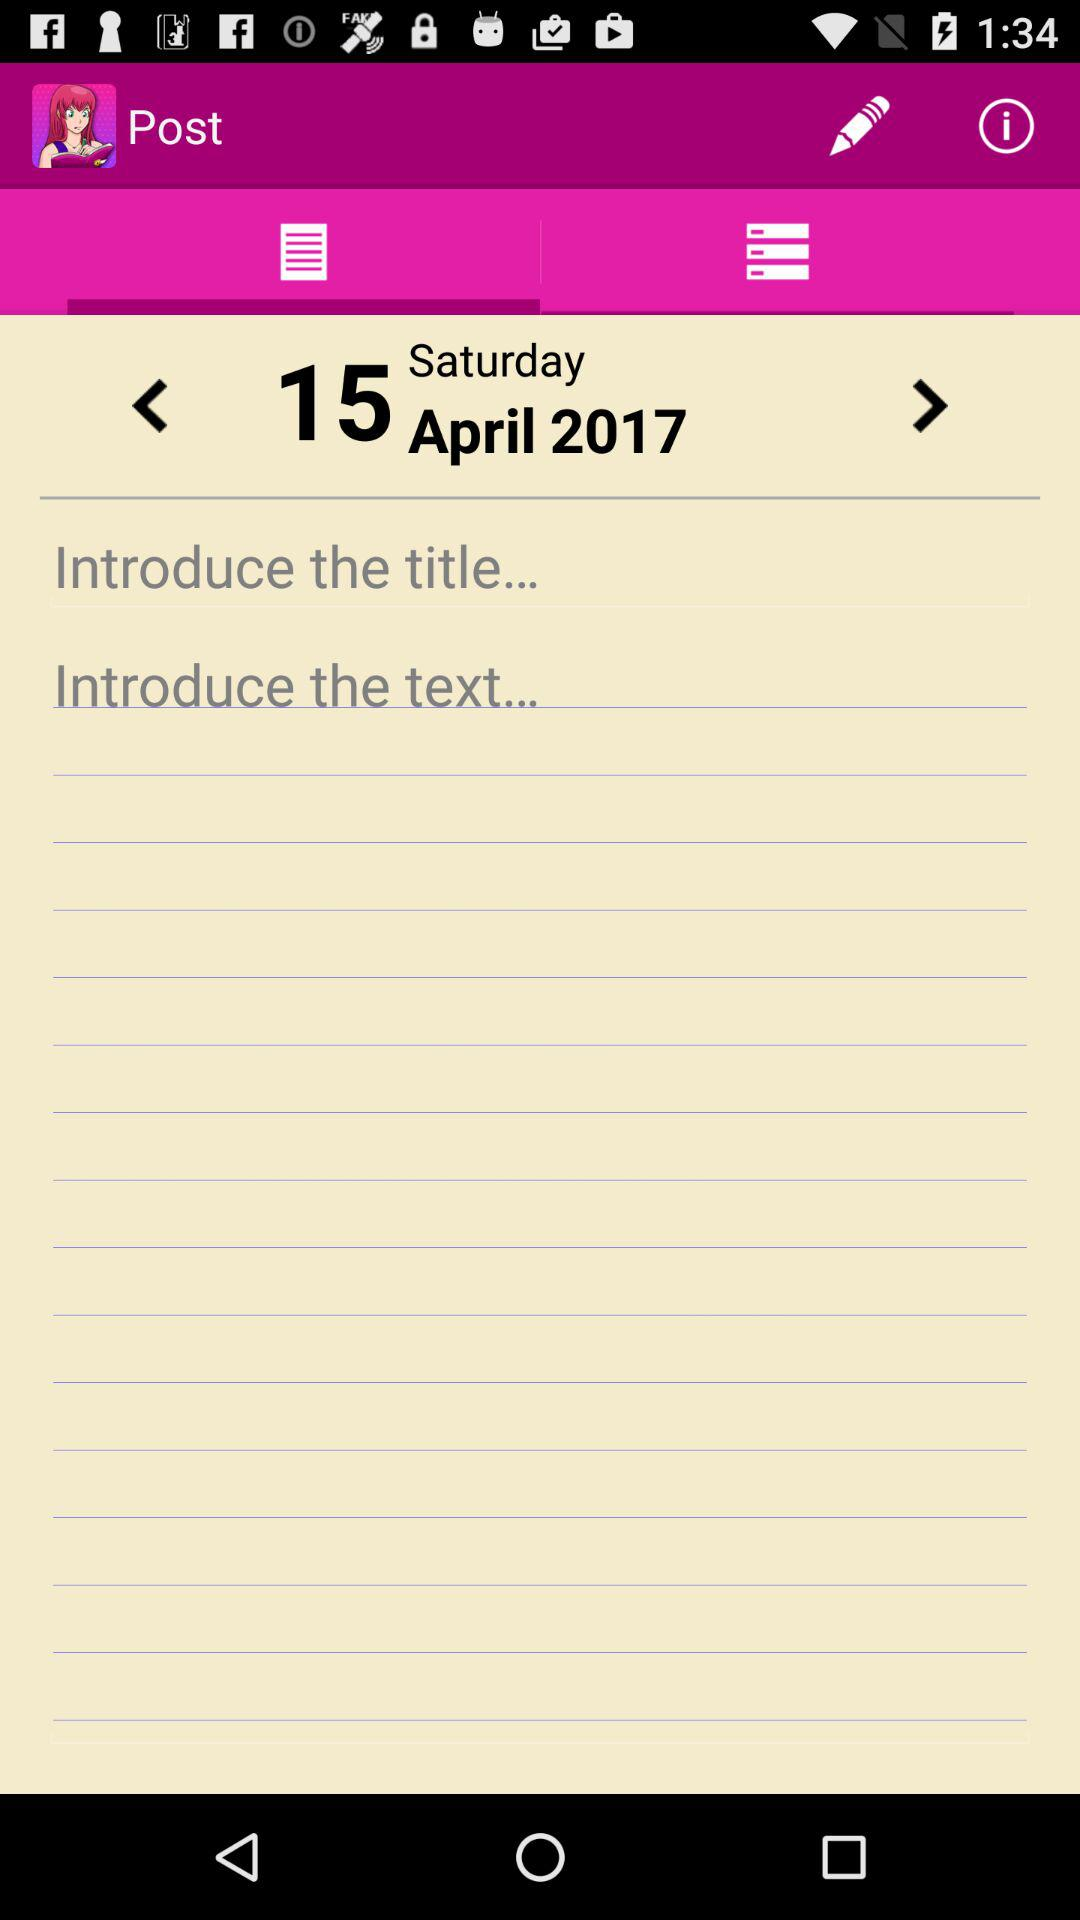What is the selected month in the calendar? The selected month is April. 